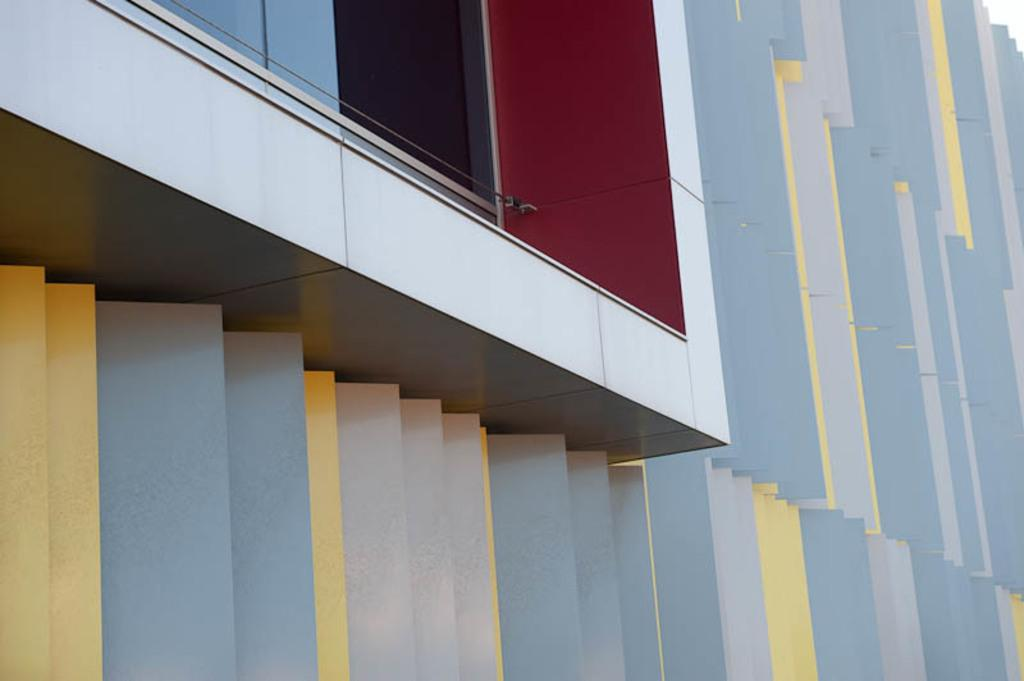What is the main structure visible in the image? There is a building in the image. Can you describe any specific features of the building? There is a glass window at the left top of the building. How many goats are standing on the roof of the building in the image? There are no goats visible on the roof of the building in the image. What type of writing can be seen on the glass window of the building? There is no writing visible on the glass window of the building in the image. 